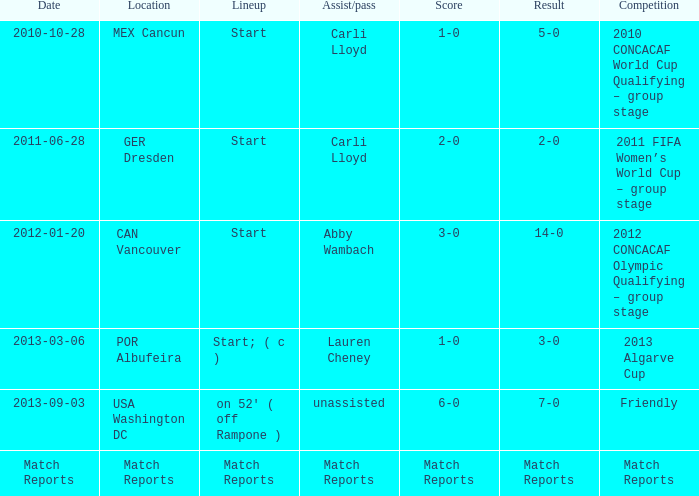Which lineup features carli lloyd's assist/pass during the 2010 concacaf world cup qualifying - group stage? Start. 